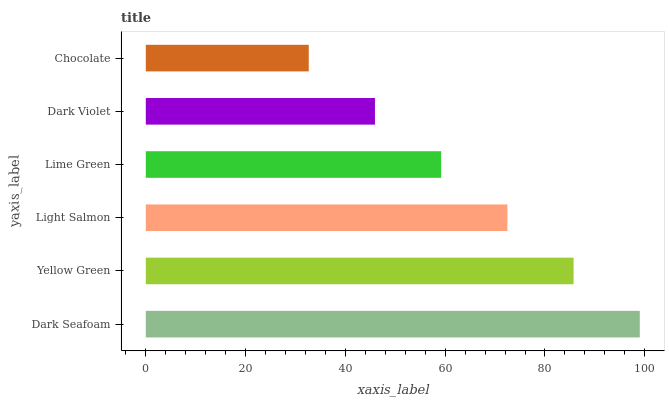Is Chocolate the minimum?
Answer yes or no. Yes. Is Dark Seafoam the maximum?
Answer yes or no. Yes. Is Yellow Green the minimum?
Answer yes or no. No. Is Yellow Green the maximum?
Answer yes or no. No. Is Dark Seafoam greater than Yellow Green?
Answer yes or no. Yes. Is Yellow Green less than Dark Seafoam?
Answer yes or no. Yes. Is Yellow Green greater than Dark Seafoam?
Answer yes or no. No. Is Dark Seafoam less than Yellow Green?
Answer yes or no. No. Is Light Salmon the high median?
Answer yes or no. Yes. Is Lime Green the low median?
Answer yes or no. Yes. Is Dark Violet the high median?
Answer yes or no. No. Is Light Salmon the low median?
Answer yes or no. No. 